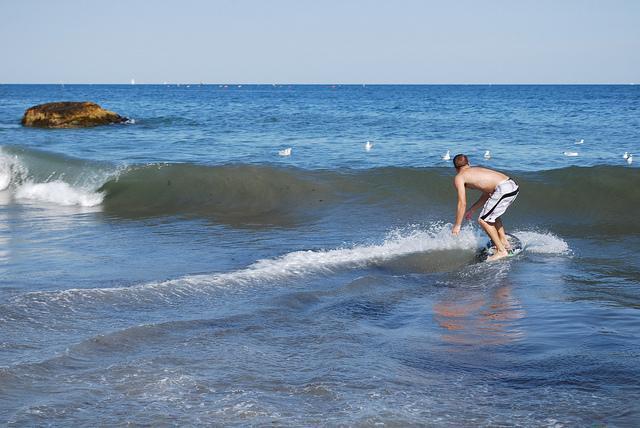How many people are pictured?
Give a very brief answer. 1. How many people in the pool?
Give a very brief answer. 1. How many people are there?
Give a very brief answer. 1. 